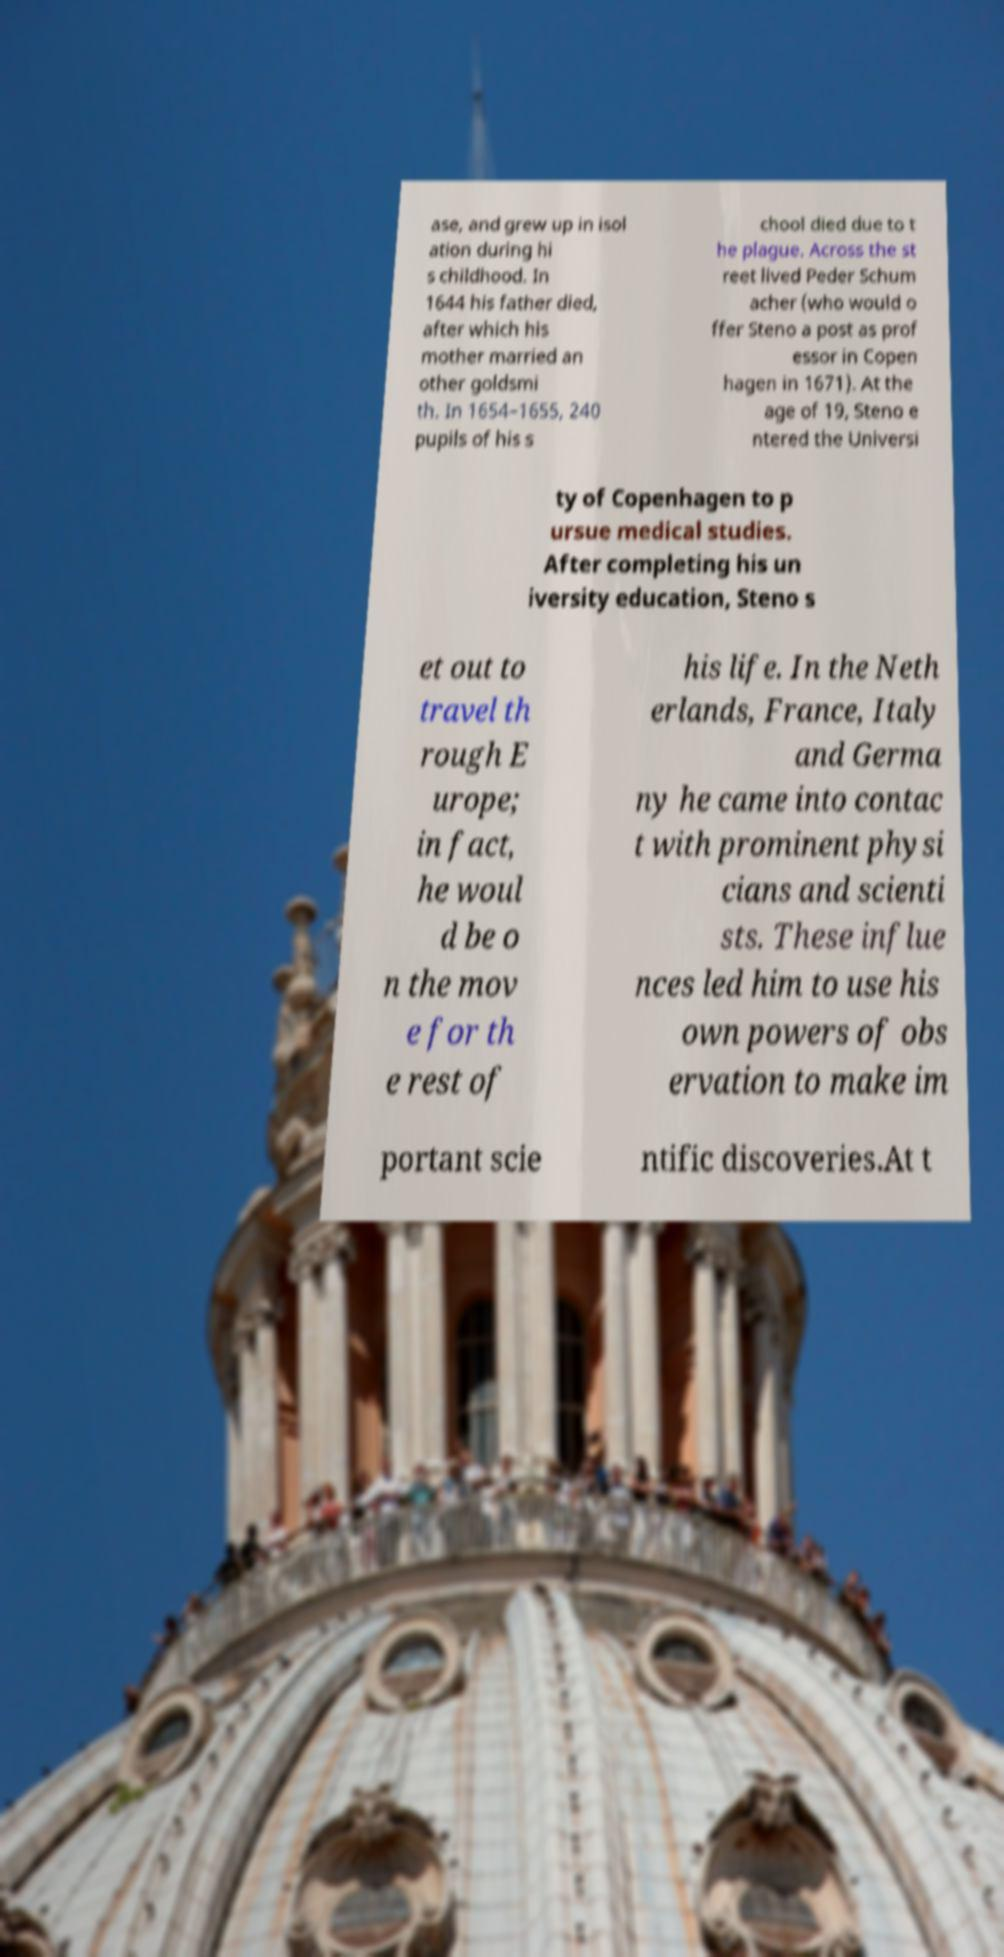Could you assist in decoding the text presented in this image and type it out clearly? ase, and grew up in isol ation during hi s childhood. In 1644 his father died, after which his mother married an other goldsmi th. In 1654–1655, 240 pupils of his s chool died due to t he plague. Across the st reet lived Peder Schum acher (who would o ffer Steno a post as prof essor in Copen hagen in 1671). At the age of 19, Steno e ntered the Universi ty of Copenhagen to p ursue medical studies. After completing his un iversity education, Steno s et out to travel th rough E urope; in fact, he woul d be o n the mov e for th e rest of his life. In the Neth erlands, France, Italy and Germa ny he came into contac t with prominent physi cians and scienti sts. These influe nces led him to use his own powers of obs ervation to make im portant scie ntific discoveries.At t 